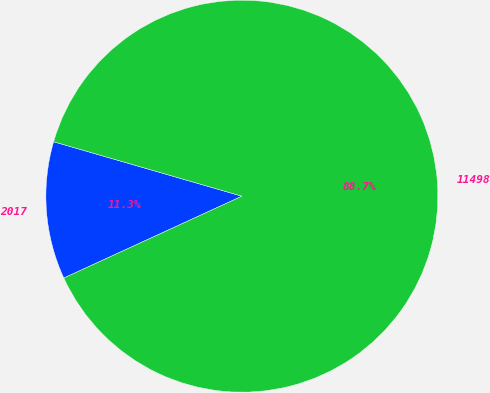Convert chart to OTSL. <chart><loc_0><loc_0><loc_500><loc_500><pie_chart><fcel>2017<fcel>11498<nl><fcel>11.34%<fcel>88.66%<nl></chart> 